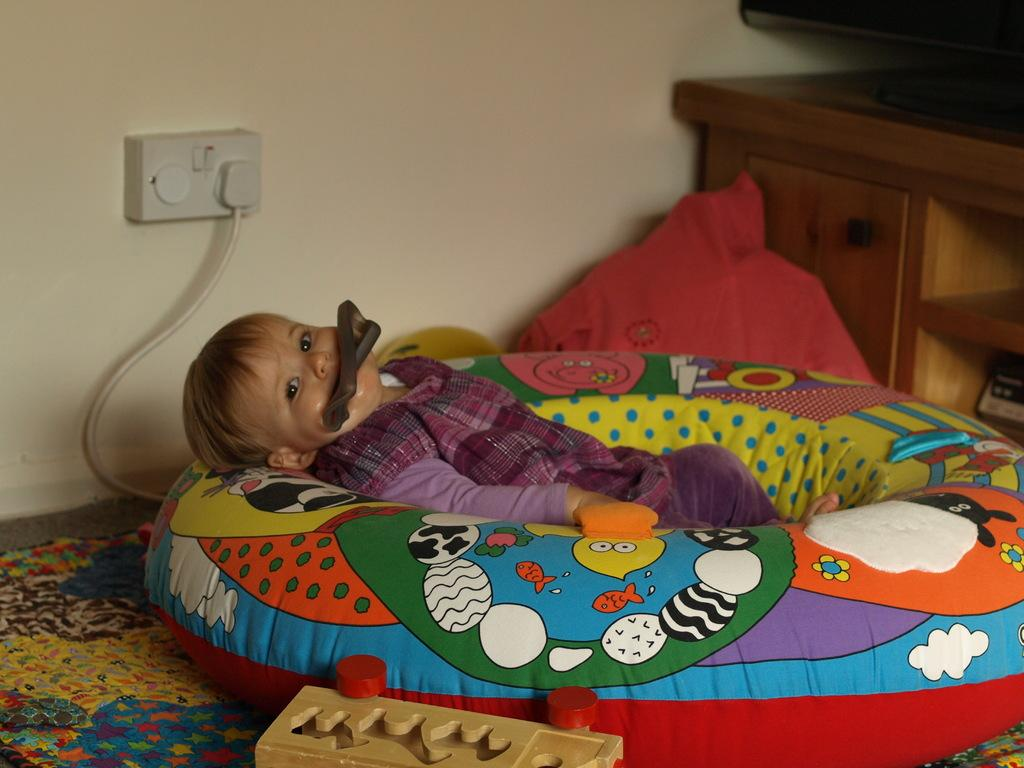What is the main subject of the image? The main subject of the image is a kid. What is the kid doing in the image? The kid is sleeping on a tube. What other objects can be seen in the image? There is a switch board and a cupboard in the image. What type of crime is being committed by the man in the image? There is no man present in the image, and therefore no crime can be observed. Can you tell me how many ducks are swimming in the water near the kid? There is no water or ducks present in the image; it features a kid sleeping on a tube with a switch board and a cupboard in the background. 